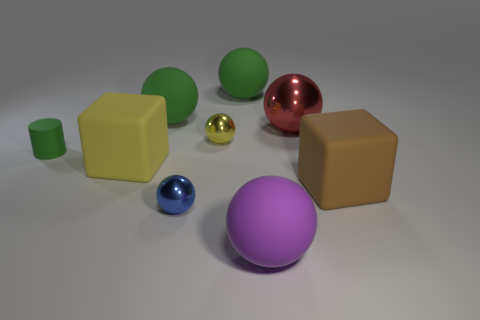Does the tiny green object have the same material as the red object?
Your response must be concise. No. Are there the same number of big red balls that are right of the red metal thing and large rubber objects that are right of the yellow ball?
Your answer should be very brief. No. There is a tiny yellow thing that is the same shape as the red shiny object; what is its material?
Make the answer very short. Metal. There is a big rubber thing to the right of the rubber ball that is on the right side of the large green ball that is to the right of the small blue thing; what is its shape?
Provide a succinct answer. Cube. Is the number of big rubber blocks behind the yellow sphere greater than the number of large yellow metal objects?
Make the answer very short. No. There is a small metal object that is in front of the large brown cube; is it the same shape as the large brown object?
Make the answer very short. No. There is a cube right of the yellow matte thing; what material is it?
Your answer should be compact. Rubber. What number of big brown rubber objects have the same shape as the red object?
Offer a very short reply. 0. What material is the big cube on the right side of the big ball in front of the big yellow block?
Ensure brevity in your answer.  Rubber. Is there another large object that has the same material as the big red thing?
Offer a terse response. No. 